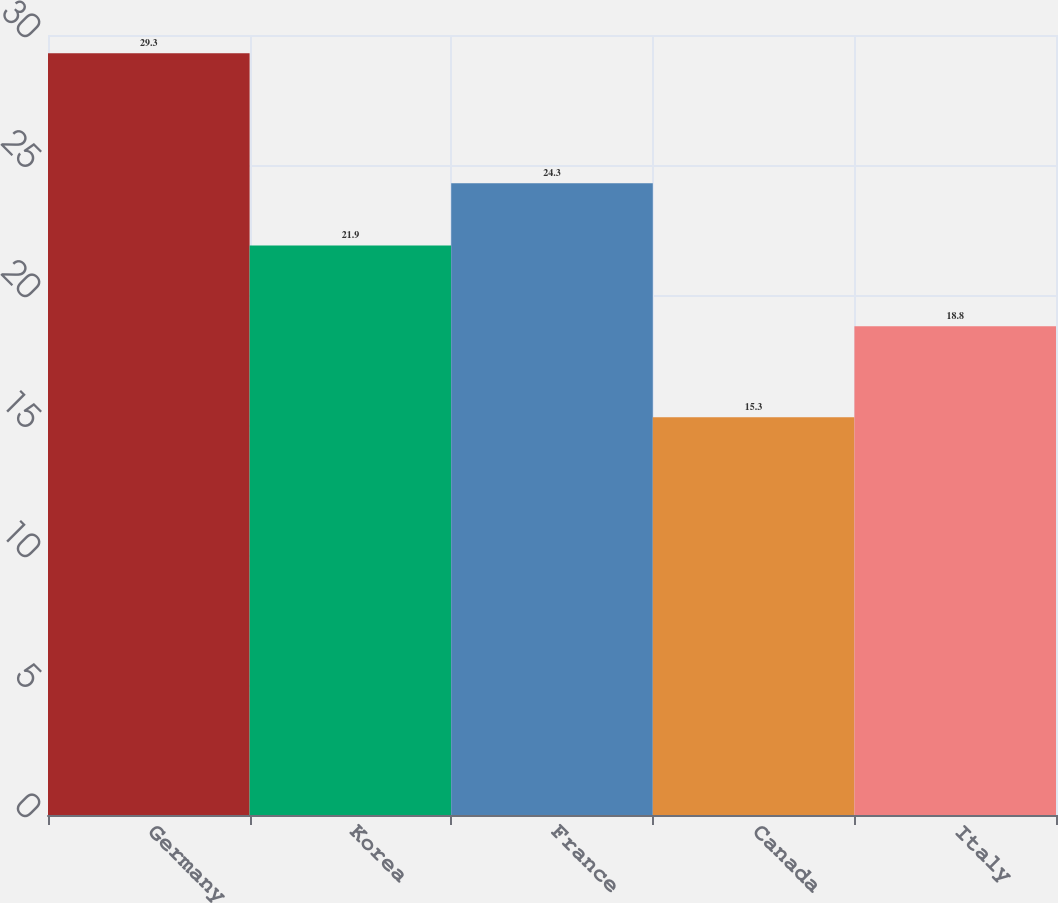Convert chart. <chart><loc_0><loc_0><loc_500><loc_500><bar_chart><fcel>Germany<fcel>Korea<fcel>France<fcel>Canada<fcel>Italy<nl><fcel>29.3<fcel>21.9<fcel>24.3<fcel>15.3<fcel>18.8<nl></chart> 